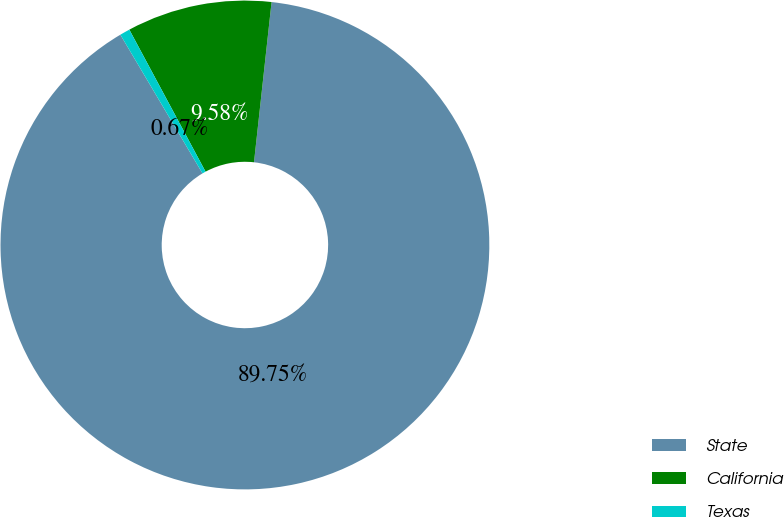Convert chart to OTSL. <chart><loc_0><loc_0><loc_500><loc_500><pie_chart><fcel>State<fcel>California<fcel>Texas<nl><fcel>89.75%<fcel>9.58%<fcel>0.67%<nl></chart> 